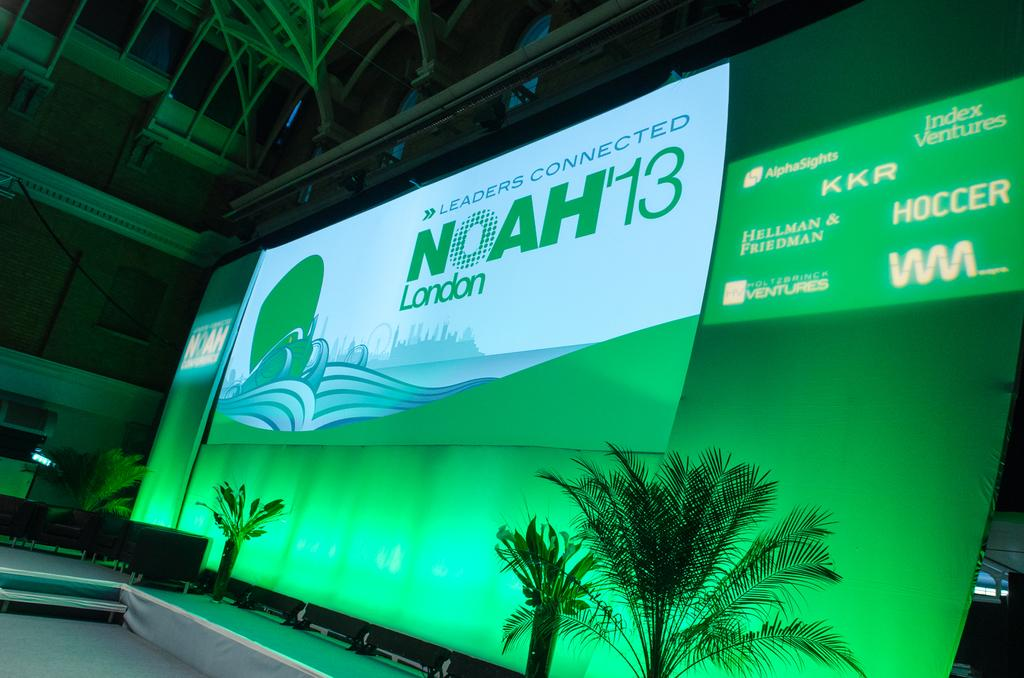What type of location is depicted in the image? The image shows an inner view of a building. What can be seen in the building? There are plants visible in the image. What is the purpose of the screen in the image? The screen is for an advertisement display. What information can be gathered from the advertisement display? The advertisement display contains some text. How much wealth does the building in the image possess? The image does not provide any information about the wealth of the building. Is there a rifle visible in the image? No, there is no rifle present in the image. 